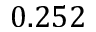<formula> <loc_0><loc_0><loc_500><loc_500>0 . 2 5 2</formula> 